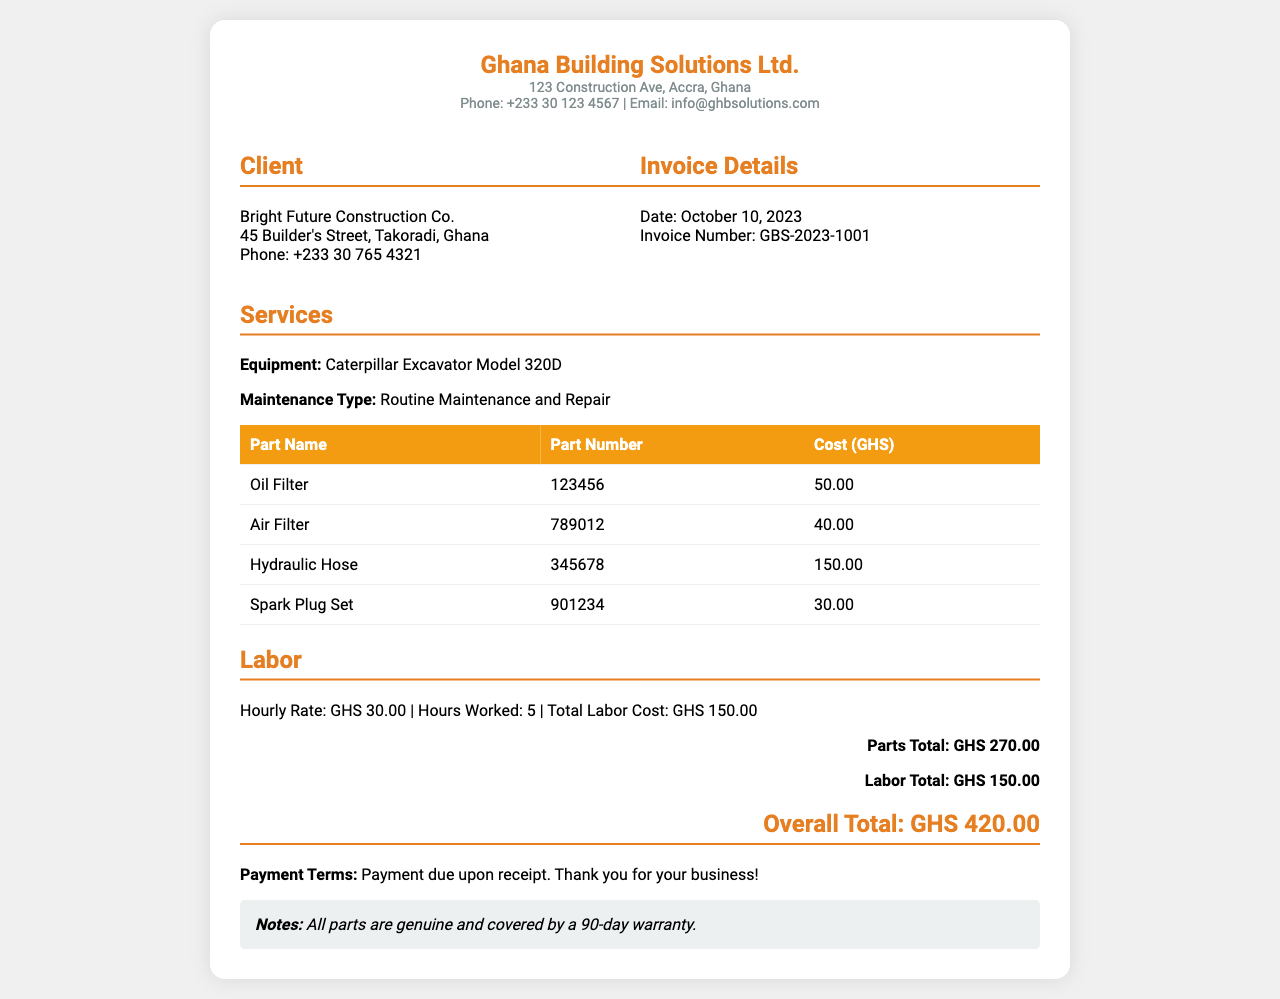what is the date of the invoice? The date is specifically mentioned in the invoice details section of the document.
Answer: October 10, 2023 who is the client? The client's name is given in the client info section of the document.
Answer: Bright Future Construction Co what is the total cost of parts? The total cost of parts is listed at the bottom of the parts table.
Answer: GHS 270.00 how many hours were worked for labor? The number of hours worked is specified in the labor section of the document.
Answer: 5 what is the invoice number? The invoice number is provided in the invoice details section.
Answer: GBS-2023-1001 what is the cost of the hydraulic hose? The cost of the hydraulic hose is noted in the parts table.
Answer: 150.00 what is the hourly labor rate? The hourly labor rate is stated in the labor section of the document.
Answer: GHS 30.00 how long is the warranty for the parts? The warranty duration is mentioned in the notes section of the document.
Answer: 90-day 